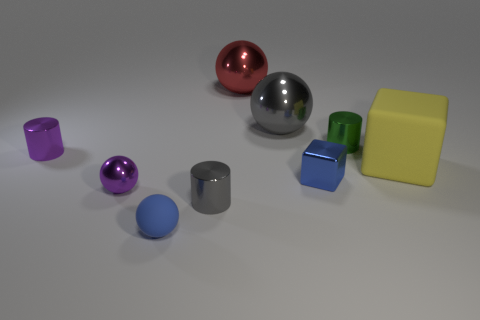Can you tell me what materials the objects might be made of based on their appearance? Based on the appearance, the objects seem to be made of materials with reflective properties, likely metals or polished plastics, giving them a shiny, smooth texture. 